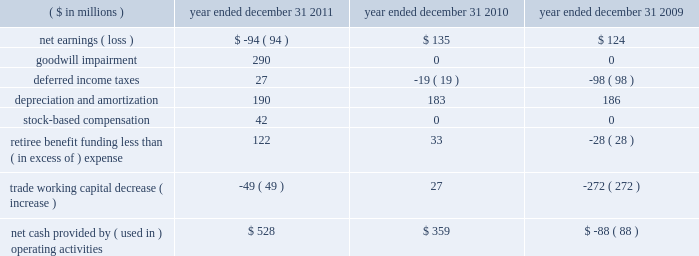Construction of cvn-79 john f .
Kennedy , construction of the u.s .
Coast guard 2019s fifth national security cutter ( unnamed ) , advance planning efforts for the cvn-72 uss abraham lincoln rcoh , and continued execution of the cvn-71 uss theodore roosevelt rcoh .
2010 2014the value of new contract awards during the year ended december 31 , 2010 , was approximately $ 3.6 billion .
Significant new awards during this period included $ 480 million for the construction of the u.s .
Coast guard 2019s fourth national security cutter hamilton , $ 480 million for design and long-lead material procurement activities for the cvn-79 john f .
Kennedy aircraft carrier , $ 377 million for cvn-78 gerald r .
Ford , $ 224 million for lha-7 ( unnamed ) , $ 184 million for lpd-26 john p .
Murtha , $ 114 million for ddg-114 ralph johnson and $ 62 million for long-lead material procurement activities for lpd-27 ( unnamed ) .
Liquidity and capital resources we endeavor to ensure the most efficient conversion of operating results into cash for deployment in operating our businesses and maximizing stockholder value .
We use various financial measures to assist in capital deployment decision making , including net cash provided by operating activities and free cash flow .
We believe these measures are useful to investors in assessing our financial performance .
The table below summarizes key components of cash flow provided by ( used in ) operating activities: .
Cash flows we discuss below our major operating , investing and financing activities for each of the three years in the period ended december 31 , 2011 , as classified on our consolidated statements of cash flows .
Operating activities 2011 2014cash provided by operating activities was $ 528 million in 2011 compared with $ 359 million in 2010 .
The increase of $ 169 million was due principally to increased earnings net of impairment charges and lower pension contributions , offset by an increase in trade working capital .
Net cash paid by northrop grumman on our behalf for u.s .
Federal income tax obligations was $ 53 million .
We expect cash generated from operations for 2012 to be sufficient to service debt , meet contract obligations , and finance capital expenditures .
Although 2012 cash from operations is expected to be sufficient to service these obligations , we may from time to time borrow funds under our credit facility to accommodate timing differences in cash flows .
2010 2014net cash provided by operating activities was $ 359 million in 2010 compared with cash used of $ 88 million in 2009 .
The change of $ 447 million was due principally to a decrease in discretionary pension contributions of $ 97 million , a decrease in trade working capital of $ 299 million , and a decrease in deferred income taxes of $ 79 million .
In 2009 , trade working capital balances included the unfavorable impact of delayed customer billings associated with the negative performance adjustments on the lpd-22 through lpd-25 contract due to projected cost increases at completion .
See note 7 : contract charges in item 8 .
The change in deferred taxes was due principally to the timing of contract related deductions .
U.s .
Federal income tax payments made by northrop grumman on our behalf were $ 89 million in 2010. .
What is the percentage change in net income from 2009 to 2010? 
Computations: ((135 - 124) / 124)
Answer: 0.08871. 